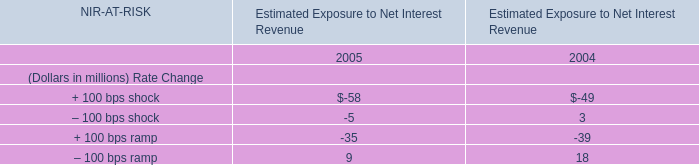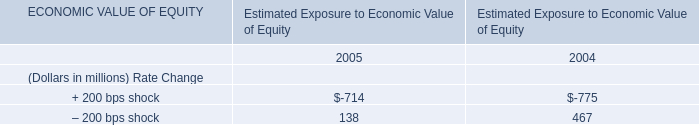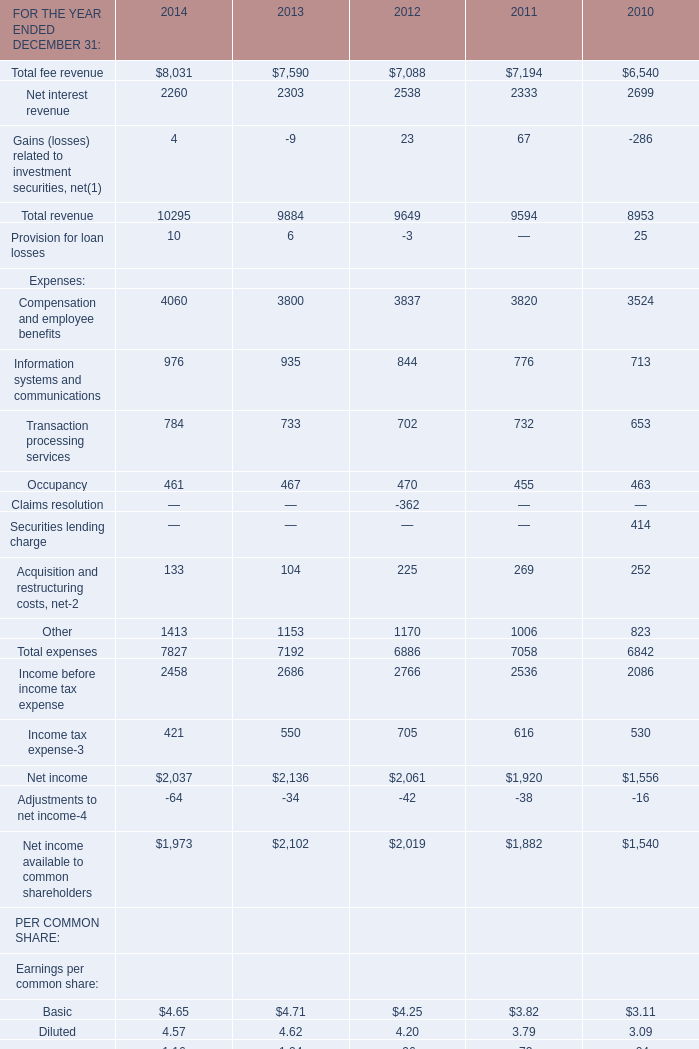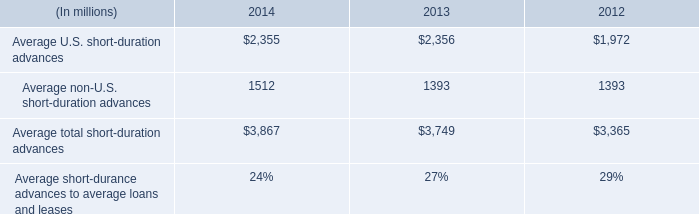What is the growing rate of Information systems and communications in the years with the least net interest revenue? (in %) 
Computations: ((976 - 935) / 935)
Answer: 0.04385. 